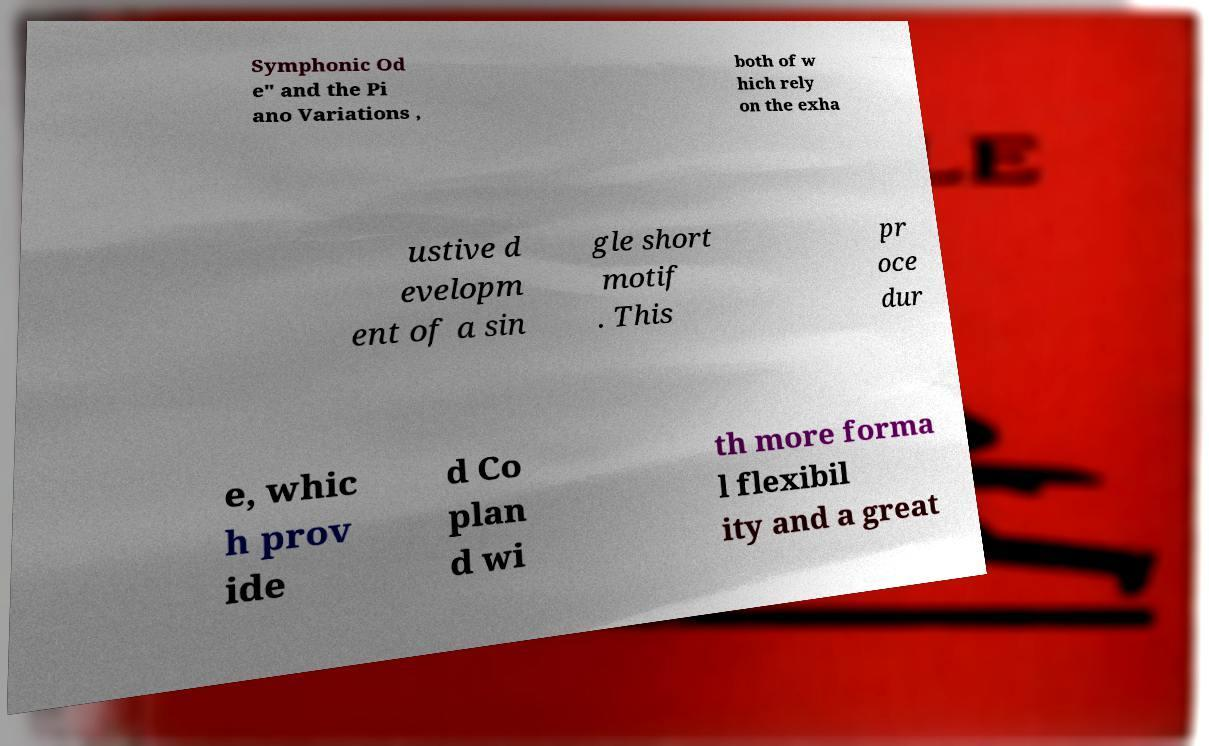Can you read and provide the text displayed in the image?This photo seems to have some interesting text. Can you extract and type it out for me? Symphonic Od e" and the Pi ano Variations , both of w hich rely on the exha ustive d evelopm ent of a sin gle short motif . This pr oce dur e, whic h prov ide d Co plan d wi th more forma l flexibil ity and a great 